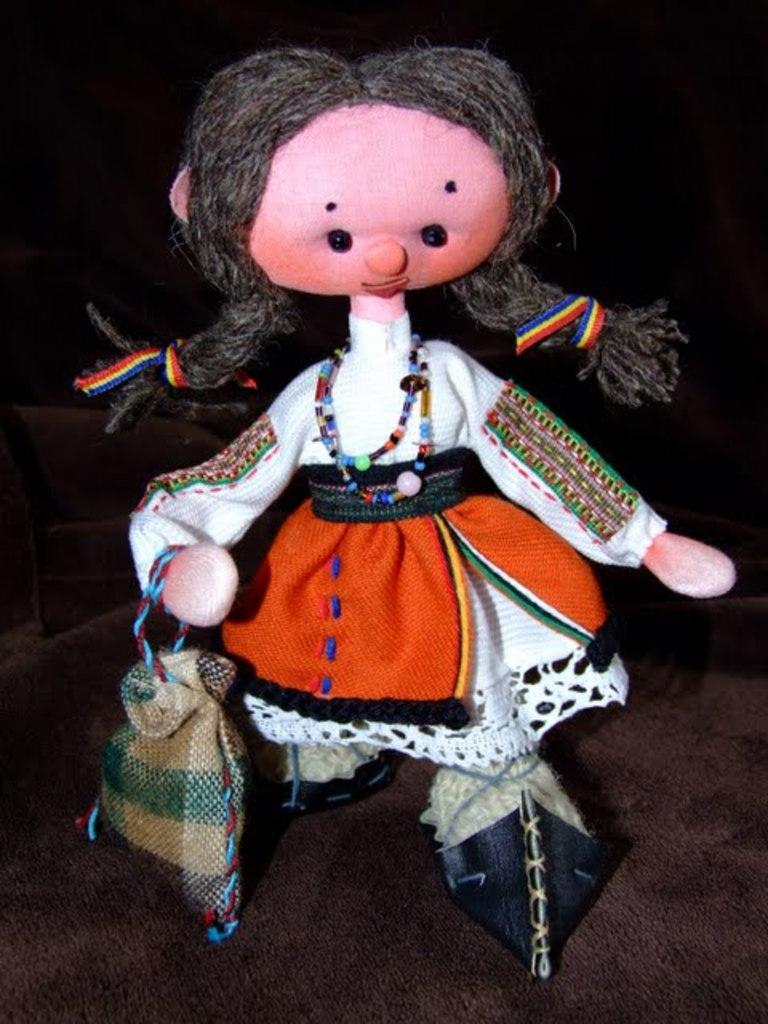What is placed on a surface in the image? There is a doll placed on a surface in the image. What type of police equipment can be seen in the image? There is no police equipment present in the image; it features a doll placed on a surface. How does the doll grip the surface in the image? The image does not provide information about the doll's grip on the surface. 